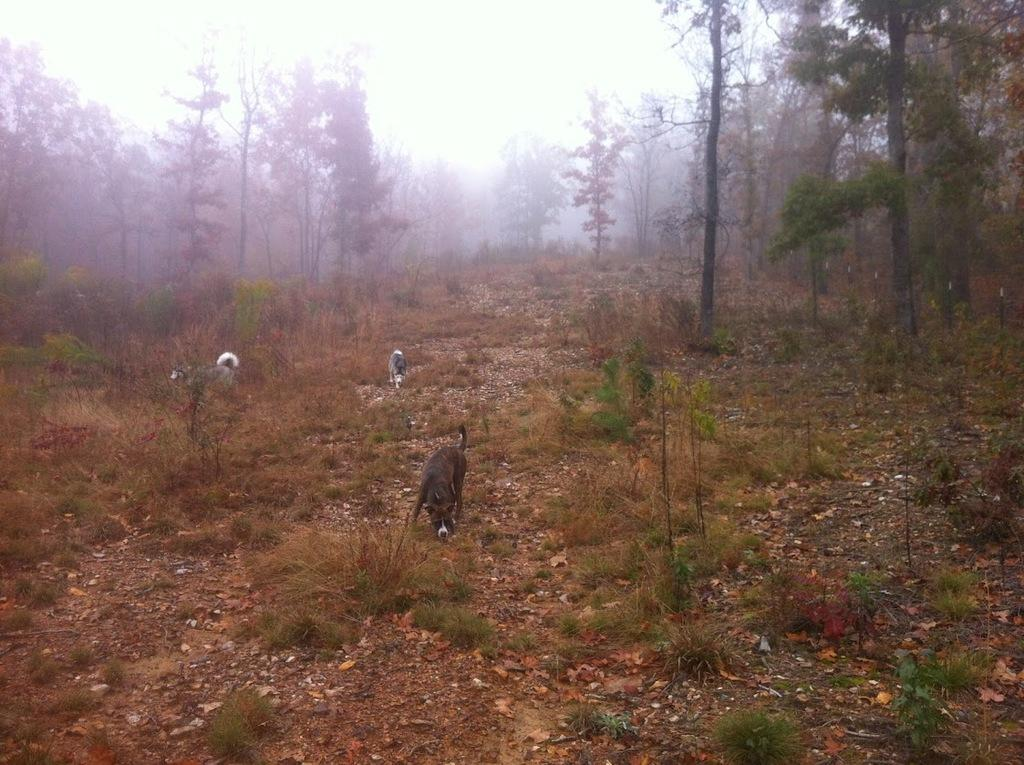What type of vegetation can be seen in the image? There are trees in the image. What other living organisms are present in the image? There are animals in the image. What is at the bottom of the image? There is grass at the bottom of the image. What is visible in the background of the image? The sky is visible in the background of the image. What type of disease is affecting the trees in the image? There is no indication of any disease affecting the trees in the image. What type of attraction is present in the image? There is no attraction present in the image; it features trees, animals, grass, and the sky. 